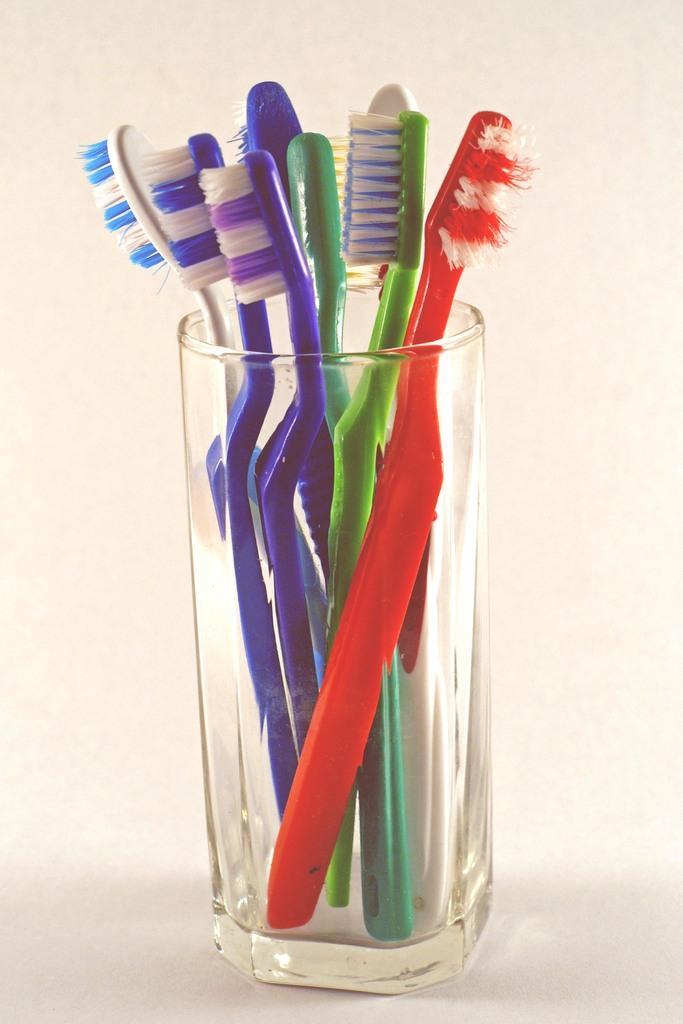Can you describe this image briefly? In this image I can see few colorful brushes in the glass. Background is in white color. 